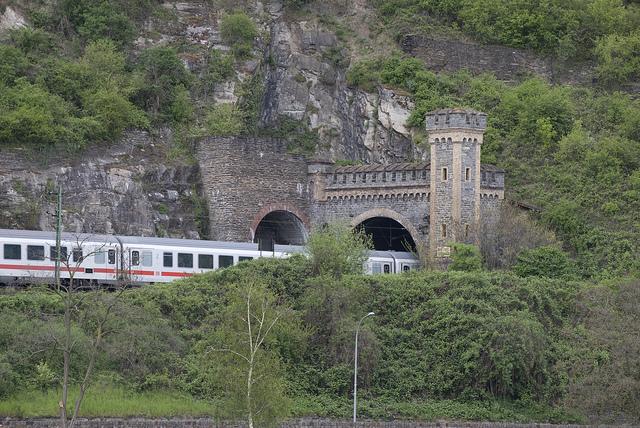What is the train riding on?
Be succinct. Tracks. How many cars of the train are visible?
Short answer required. 3. Is this in America?
Short answer required. No. Is this architecture made of stone?
Quick response, please. Yes. 